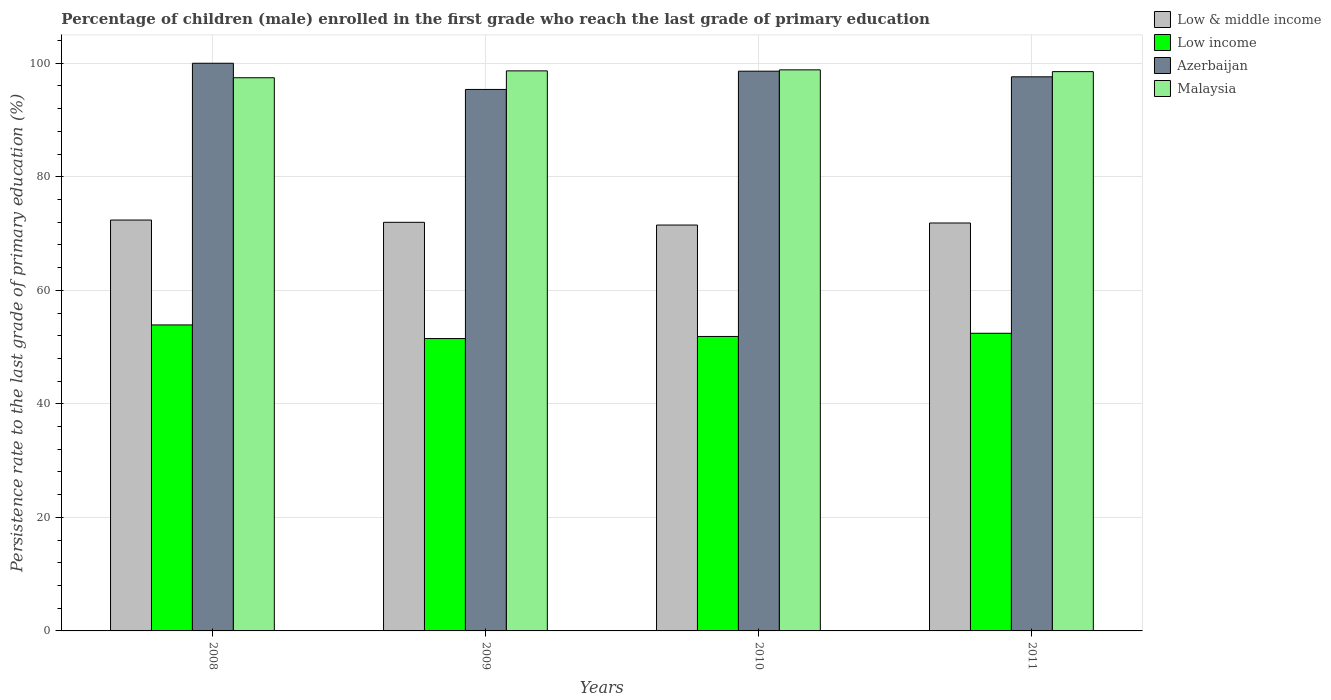How many different coloured bars are there?
Ensure brevity in your answer.  4. How many groups of bars are there?
Make the answer very short. 4. Are the number of bars on each tick of the X-axis equal?
Offer a very short reply. Yes. How many bars are there on the 2nd tick from the left?
Ensure brevity in your answer.  4. How many bars are there on the 4th tick from the right?
Make the answer very short. 4. What is the persistence rate of children in Low & middle income in 2010?
Ensure brevity in your answer.  71.49. Across all years, what is the maximum persistence rate of children in Azerbaijan?
Offer a very short reply. 99.99. Across all years, what is the minimum persistence rate of children in Low income?
Your response must be concise. 51.5. In which year was the persistence rate of children in Low & middle income maximum?
Ensure brevity in your answer.  2008. In which year was the persistence rate of children in Azerbaijan minimum?
Offer a terse response. 2009. What is the total persistence rate of children in Low & middle income in the graph?
Your answer should be compact. 287.7. What is the difference between the persistence rate of children in Malaysia in 2010 and that in 2011?
Your answer should be compact. 0.31. What is the difference between the persistence rate of children in Low income in 2008 and the persistence rate of children in Malaysia in 2009?
Provide a succinct answer. -44.75. What is the average persistence rate of children in Malaysia per year?
Keep it short and to the point. 98.36. In the year 2010, what is the difference between the persistence rate of children in Low income and persistence rate of children in Azerbaijan?
Your answer should be very brief. -46.73. What is the ratio of the persistence rate of children in Azerbaijan in 2009 to that in 2011?
Give a very brief answer. 0.98. Is the persistence rate of children in Azerbaijan in 2009 less than that in 2011?
Provide a succinct answer. Yes. Is the difference between the persistence rate of children in Low income in 2008 and 2011 greater than the difference between the persistence rate of children in Azerbaijan in 2008 and 2011?
Provide a succinct answer. No. What is the difference between the highest and the second highest persistence rate of children in Azerbaijan?
Your answer should be compact. 1.39. What is the difference between the highest and the lowest persistence rate of children in Malaysia?
Provide a short and direct response. 1.39. In how many years, is the persistence rate of children in Azerbaijan greater than the average persistence rate of children in Azerbaijan taken over all years?
Your answer should be compact. 2. Is the sum of the persistence rate of children in Low & middle income in 2010 and 2011 greater than the maximum persistence rate of children in Low income across all years?
Provide a succinct answer. Yes. Is it the case that in every year, the sum of the persistence rate of children in Low income and persistence rate of children in Malaysia is greater than the sum of persistence rate of children in Low & middle income and persistence rate of children in Azerbaijan?
Offer a very short reply. No. What does the 2nd bar from the left in 2009 represents?
Your answer should be very brief. Low income. What does the 1st bar from the right in 2010 represents?
Offer a terse response. Malaysia. How many bars are there?
Provide a succinct answer. 16. Are all the bars in the graph horizontal?
Offer a very short reply. No. What is the difference between two consecutive major ticks on the Y-axis?
Offer a very short reply. 20. Does the graph contain any zero values?
Provide a short and direct response. No. Does the graph contain grids?
Provide a succinct answer. Yes. Where does the legend appear in the graph?
Keep it short and to the point. Top right. How many legend labels are there?
Your answer should be compact. 4. What is the title of the graph?
Give a very brief answer. Percentage of children (male) enrolled in the first grade who reach the last grade of primary education. What is the label or title of the X-axis?
Offer a very short reply. Years. What is the label or title of the Y-axis?
Offer a terse response. Persistence rate to the last grade of primary education (%). What is the Persistence rate to the last grade of primary education (%) of Low & middle income in 2008?
Make the answer very short. 72.38. What is the Persistence rate to the last grade of primary education (%) in Low income in 2008?
Provide a short and direct response. 53.9. What is the Persistence rate to the last grade of primary education (%) of Azerbaijan in 2008?
Your response must be concise. 99.99. What is the Persistence rate to the last grade of primary education (%) in Malaysia in 2008?
Provide a succinct answer. 97.44. What is the Persistence rate to the last grade of primary education (%) of Low & middle income in 2009?
Give a very brief answer. 71.97. What is the Persistence rate to the last grade of primary education (%) in Low income in 2009?
Provide a succinct answer. 51.5. What is the Persistence rate to the last grade of primary education (%) in Azerbaijan in 2009?
Make the answer very short. 95.38. What is the Persistence rate to the last grade of primary education (%) of Malaysia in 2009?
Your answer should be very brief. 98.65. What is the Persistence rate to the last grade of primary education (%) in Low & middle income in 2010?
Offer a very short reply. 71.49. What is the Persistence rate to the last grade of primary education (%) in Low income in 2010?
Offer a very short reply. 51.87. What is the Persistence rate to the last grade of primary education (%) in Azerbaijan in 2010?
Give a very brief answer. 98.6. What is the Persistence rate to the last grade of primary education (%) of Malaysia in 2010?
Make the answer very short. 98.83. What is the Persistence rate to the last grade of primary education (%) of Low & middle income in 2011?
Your response must be concise. 71.86. What is the Persistence rate to the last grade of primary education (%) in Low income in 2011?
Make the answer very short. 52.43. What is the Persistence rate to the last grade of primary education (%) in Azerbaijan in 2011?
Ensure brevity in your answer.  97.6. What is the Persistence rate to the last grade of primary education (%) in Malaysia in 2011?
Provide a succinct answer. 98.52. Across all years, what is the maximum Persistence rate to the last grade of primary education (%) of Low & middle income?
Offer a very short reply. 72.38. Across all years, what is the maximum Persistence rate to the last grade of primary education (%) in Low income?
Your answer should be very brief. 53.9. Across all years, what is the maximum Persistence rate to the last grade of primary education (%) in Azerbaijan?
Make the answer very short. 99.99. Across all years, what is the maximum Persistence rate to the last grade of primary education (%) in Malaysia?
Keep it short and to the point. 98.83. Across all years, what is the minimum Persistence rate to the last grade of primary education (%) of Low & middle income?
Your response must be concise. 71.49. Across all years, what is the minimum Persistence rate to the last grade of primary education (%) in Low income?
Ensure brevity in your answer.  51.5. Across all years, what is the minimum Persistence rate to the last grade of primary education (%) in Azerbaijan?
Make the answer very short. 95.38. Across all years, what is the minimum Persistence rate to the last grade of primary education (%) in Malaysia?
Make the answer very short. 97.44. What is the total Persistence rate to the last grade of primary education (%) in Low & middle income in the graph?
Provide a succinct answer. 287.7. What is the total Persistence rate to the last grade of primary education (%) of Low income in the graph?
Offer a terse response. 209.7. What is the total Persistence rate to the last grade of primary education (%) of Azerbaijan in the graph?
Give a very brief answer. 391.58. What is the total Persistence rate to the last grade of primary education (%) of Malaysia in the graph?
Make the answer very short. 393.44. What is the difference between the Persistence rate to the last grade of primary education (%) of Low & middle income in 2008 and that in 2009?
Make the answer very short. 0.4. What is the difference between the Persistence rate to the last grade of primary education (%) of Low income in 2008 and that in 2009?
Ensure brevity in your answer.  2.4. What is the difference between the Persistence rate to the last grade of primary education (%) of Azerbaijan in 2008 and that in 2009?
Provide a succinct answer. 4.61. What is the difference between the Persistence rate to the last grade of primary education (%) in Malaysia in 2008 and that in 2009?
Make the answer very short. -1.21. What is the difference between the Persistence rate to the last grade of primary education (%) of Low & middle income in 2008 and that in 2010?
Your response must be concise. 0.88. What is the difference between the Persistence rate to the last grade of primary education (%) in Low income in 2008 and that in 2010?
Offer a very short reply. 2.03. What is the difference between the Persistence rate to the last grade of primary education (%) in Azerbaijan in 2008 and that in 2010?
Your answer should be compact. 1.39. What is the difference between the Persistence rate to the last grade of primary education (%) of Malaysia in 2008 and that in 2010?
Your answer should be compact. -1.39. What is the difference between the Persistence rate to the last grade of primary education (%) of Low & middle income in 2008 and that in 2011?
Ensure brevity in your answer.  0.52. What is the difference between the Persistence rate to the last grade of primary education (%) of Low income in 2008 and that in 2011?
Provide a short and direct response. 1.47. What is the difference between the Persistence rate to the last grade of primary education (%) in Azerbaijan in 2008 and that in 2011?
Keep it short and to the point. 2.39. What is the difference between the Persistence rate to the last grade of primary education (%) of Malaysia in 2008 and that in 2011?
Make the answer very short. -1.08. What is the difference between the Persistence rate to the last grade of primary education (%) in Low & middle income in 2009 and that in 2010?
Your answer should be compact. 0.48. What is the difference between the Persistence rate to the last grade of primary education (%) of Low income in 2009 and that in 2010?
Provide a short and direct response. -0.37. What is the difference between the Persistence rate to the last grade of primary education (%) in Azerbaijan in 2009 and that in 2010?
Keep it short and to the point. -3.22. What is the difference between the Persistence rate to the last grade of primary education (%) in Malaysia in 2009 and that in 2010?
Offer a terse response. -0.18. What is the difference between the Persistence rate to the last grade of primary education (%) in Low & middle income in 2009 and that in 2011?
Keep it short and to the point. 0.12. What is the difference between the Persistence rate to the last grade of primary education (%) of Low income in 2009 and that in 2011?
Your response must be concise. -0.93. What is the difference between the Persistence rate to the last grade of primary education (%) of Azerbaijan in 2009 and that in 2011?
Give a very brief answer. -2.22. What is the difference between the Persistence rate to the last grade of primary education (%) in Malaysia in 2009 and that in 2011?
Your response must be concise. 0.13. What is the difference between the Persistence rate to the last grade of primary education (%) in Low & middle income in 2010 and that in 2011?
Provide a short and direct response. -0.36. What is the difference between the Persistence rate to the last grade of primary education (%) in Low income in 2010 and that in 2011?
Provide a succinct answer. -0.56. What is the difference between the Persistence rate to the last grade of primary education (%) of Azerbaijan in 2010 and that in 2011?
Provide a short and direct response. 0.99. What is the difference between the Persistence rate to the last grade of primary education (%) of Malaysia in 2010 and that in 2011?
Provide a succinct answer. 0.31. What is the difference between the Persistence rate to the last grade of primary education (%) in Low & middle income in 2008 and the Persistence rate to the last grade of primary education (%) in Low income in 2009?
Your answer should be compact. 20.87. What is the difference between the Persistence rate to the last grade of primary education (%) of Low & middle income in 2008 and the Persistence rate to the last grade of primary education (%) of Azerbaijan in 2009?
Provide a succinct answer. -23. What is the difference between the Persistence rate to the last grade of primary education (%) in Low & middle income in 2008 and the Persistence rate to the last grade of primary education (%) in Malaysia in 2009?
Provide a short and direct response. -26.28. What is the difference between the Persistence rate to the last grade of primary education (%) in Low income in 2008 and the Persistence rate to the last grade of primary education (%) in Azerbaijan in 2009?
Offer a terse response. -41.48. What is the difference between the Persistence rate to the last grade of primary education (%) of Low income in 2008 and the Persistence rate to the last grade of primary education (%) of Malaysia in 2009?
Give a very brief answer. -44.75. What is the difference between the Persistence rate to the last grade of primary education (%) in Azerbaijan in 2008 and the Persistence rate to the last grade of primary education (%) in Malaysia in 2009?
Offer a terse response. 1.34. What is the difference between the Persistence rate to the last grade of primary education (%) in Low & middle income in 2008 and the Persistence rate to the last grade of primary education (%) in Low income in 2010?
Your answer should be very brief. 20.51. What is the difference between the Persistence rate to the last grade of primary education (%) in Low & middle income in 2008 and the Persistence rate to the last grade of primary education (%) in Azerbaijan in 2010?
Offer a very short reply. -26.22. What is the difference between the Persistence rate to the last grade of primary education (%) of Low & middle income in 2008 and the Persistence rate to the last grade of primary education (%) of Malaysia in 2010?
Your answer should be compact. -26.46. What is the difference between the Persistence rate to the last grade of primary education (%) of Low income in 2008 and the Persistence rate to the last grade of primary education (%) of Azerbaijan in 2010?
Your response must be concise. -44.7. What is the difference between the Persistence rate to the last grade of primary education (%) in Low income in 2008 and the Persistence rate to the last grade of primary education (%) in Malaysia in 2010?
Offer a terse response. -44.93. What is the difference between the Persistence rate to the last grade of primary education (%) in Azerbaijan in 2008 and the Persistence rate to the last grade of primary education (%) in Malaysia in 2010?
Your answer should be compact. 1.16. What is the difference between the Persistence rate to the last grade of primary education (%) of Low & middle income in 2008 and the Persistence rate to the last grade of primary education (%) of Low income in 2011?
Your response must be concise. 19.95. What is the difference between the Persistence rate to the last grade of primary education (%) of Low & middle income in 2008 and the Persistence rate to the last grade of primary education (%) of Azerbaijan in 2011?
Offer a terse response. -25.23. What is the difference between the Persistence rate to the last grade of primary education (%) in Low & middle income in 2008 and the Persistence rate to the last grade of primary education (%) in Malaysia in 2011?
Offer a terse response. -26.14. What is the difference between the Persistence rate to the last grade of primary education (%) in Low income in 2008 and the Persistence rate to the last grade of primary education (%) in Azerbaijan in 2011?
Your response must be concise. -43.7. What is the difference between the Persistence rate to the last grade of primary education (%) of Low income in 2008 and the Persistence rate to the last grade of primary education (%) of Malaysia in 2011?
Offer a terse response. -44.62. What is the difference between the Persistence rate to the last grade of primary education (%) in Azerbaijan in 2008 and the Persistence rate to the last grade of primary education (%) in Malaysia in 2011?
Make the answer very short. 1.48. What is the difference between the Persistence rate to the last grade of primary education (%) of Low & middle income in 2009 and the Persistence rate to the last grade of primary education (%) of Low income in 2010?
Keep it short and to the point. 20.11. What is the difference between the Persistence rate to the last grade of primary education (%) in Low & middle income in 2009 and the Persistence rate to the last grade of primary education (%) in Azerbaijan in 2010?
Provide a succinct answer. -26.62. What is the difference between the Persistence rate to the last grade of primary education (%) in Low & middle income in 2009 and the Persistence rate to the last grade of primary education (%) in Malaysia in 2010?
Keep it short and to the point. -26.86. What is the difference between the Persistence rate to the last grade of primary education (%) in Low income in 2009 and the Persistence rate to the last grade of primary education (%) in Azerbaijan in 2010?
Offer a very short reply. -47.1. What is the difference between the Persistence rate to the last grade of primary education (%) in Low income in 2009 and the Persistence rate to the last grade of primary education (%) in Malaysia in 2010?
Your answer should be very brief. -47.33. What is the difference between the Persistence rate to the last grade of primary education (%) in Azerbaijan in 2009 and the Persistence rate to the last grade of primary education (%) in Malaysia in 2010?
Make the answer very short. -3.45. What is the difference between the Persistence rate to the last grade of primary education (%) of Low & middle income in 2009 and the Persistence rate to the last grade of primary education (%) of Low income in 2011?
Make the answer very short. 19.54. What is the difference between the Persistence rate to the last grade of primary education (%) of Low & middle income in 2009 and the Persistence rate to the last grade of primary education (%) of Azerbaijan in 2011?
Your answer should be compact. -25.63. What is the difference between the Persistence rate to the last grade of primary education (%) in Low & middle income in 2009 and the Persistence rate to the last grade of primary education (%) in Malaysia in 2011?
Provide a short and direct response. -26.54. What is the difference between the Persistence rate to the last grade of primary education (%) of Low income in 2009 and the Persistence rate to the last grade of primary education (%) of Azerbaijan in 2011?
Offer a very short reply. -46.1. What is the difference between the Persistence rate to the last grade of primary education (%) in Low income in 2009 and the Persistence rate to the last grade of primary education (%) in Malaysia in 2011?
Your response must be concise. -47.02. What is the difference between the Persistence rate to the last grade of primary education (%) in Azerbaijan in 2009 and the Persistence rate to the last grade of primary education (%) in Malaysia in 2011?
Provide a succinct answer. -3.14. What is the difference between the Persistence rate to the last grade of primary education (%) in Low & middle income in 2010 and the Persistence rate to the last grade of primary education (%) in Low income in 2011?
Give a very brief answer. 19.06. What is the difference between the Persistence rate to the last grade of primary education (%) in Low & middle income in 2010 and the Persistence rate to the last grade of primary education (%) in Azerbaijan in 2011?
Offer a terse response. -26.11. What is the difference between the Persistence rate to the last grade of primary education (%) in Low & middle income in 2010 and the Persistence rate to the last grade of primary education (%) in Malaysia in 2011?
Offer a very short reply. -27.02. What is the difference between the Persistence rate to the last grade of primary education (%) of Low income in 2010 and the Persistence rate to the last grade of primary education (%) of Azerbaijan in 2011?
Offer a very short reply. -45.73. What is the difference between the Persistence rate to the last grade of primary education (%) of Low income in 2010 and the Persistence rate to the last grade of primary education (%) of Malaysia in 2011?
Give a very brief answer. -46.65. What is the difference between the Persistence rate to the last grade of primary education (%) in Azerbaijan in 2010 and the Persistence rate to the last grade of primary education (%) in Malaysia in 2011?
Provide a succinct answer. 0.08. What is the average Persistence rate to the last grade of primary education (%) of Low & middle income per year?
Offer a very short reply. 71.93. What is the average Persistence rate to the last grade of primary education (%) in Low income per year?
Ensure brevity in your answer.  52.43. What is the average Persistence rate to the last grade of primary education (%) in Azerbaijan per year?
Give a very brief answer. 97.89. What is the average Persistence rate to the last grade of primary education (%) of Malaysia per year?
Your response must be concise. 98.36. In the year 2008, what is the difference between the Persistence rate to the last grade of primary education (%) of Low & middle income and Persistence rate to the last grade of primary education (%) of Low income?
Your response must be concise. 18.47. In the year 2008, what is the difference between the Persistence rate to the last grade of primary education (%) of Low & middle income and Persistence rate to the last grade of primary education (%) of Azerbaijan?
Make the answer very short. -27.62. In the year 2008, what is the difference between the Persistence rate to the last grade of primary education (%) of Low & middle income and Persistence rate to the last grade of primary education (%) of Malaysia?
Provide a short and direct response. -25.07. In the year 2008, what is the difference between the Persistence rate to the last grade of primary education (%) in Low income and Persistence rate to the last grade of primary education (%) in Azerbaijan?
Your answer should be very brief. -46.09. In the year 2008, what is the difference between the Persistence rate to the last grade of primary education (%) of Low income and Persistence rate to the last grade of primary education (%) of Malaysia?
Your response must be concise. -43.54. In the year 2008, what is the difference between the Persistence rate to the last grade of primary education (%) of Azerbaijan and Persistence rate to the last grade of primary education (%) of Malaysia?
Your response must be concise. 2.55. In the year 2009, what is the difference between the Persistence rate to the last grade of primary education (%) in Low & middle income and Persistence rate to the last grade of primary education (%) in Low income?
Keep it short and to the point. 20.47. In the year 2009, what is the difference between the Persistence rate to the last grade of primary education (%) in Low & middle income and Persistence rate to the last grade of primary education (%) in Azerbaijan?
Keep it short and to the point. -23.4. In the year 2009, what is the difference between the Persistence rate to the last grade of primary education (%) in Low & middle income and Persistence rate to the last grade of primary education (%) in Malaysia?
Your answer should be compact. -26.68. In the year 2009, what is the difference between the Persistence rate to the last grade of primary education (%) of Low income and Persistence rate to the last grade of primary education (%) of Azerbaijan?
Make the answer very short. -43.88. In the year 2009, what is the difference between the Persistence rate to the last grade of primary education (%) in Low income and Persistence rate to the last grade of primary education (%) in Malaysia?
Make the answer very short. -47.15. In the year 2009, what is the difference between the Persistence rate to the last grade of primary education (%) of Azerbaijan and Persistence rate to the last grade of primary education (%) of Malaysia?
Keep it short and to the point. -3.27. In the year 2010, what is the difference between the Persistence rate to the last grade of primary education (%) in Low & middle income and Persistence rate to the last grade of primary education (%) in Low income?
Your answer should be compact. 19.63. In the year 2010, what is the difference between the Persistence rate to the last grade of primary education (%) in Low & middle income and Persistence rate to the last grade of primary education (%) in Azerbaijan?
Offer a terse response. -27.1. In the year 2010, what is the difference between the Persistence rate to the last grade of primary education (%) in Low & middle income and Persistence rate to the last grade of primary education (%) in Malaysia?
Offer a terse response. -27.34. In the year 2010, what is the difference between the Persistence rate to the last grade of primary education (%) of Low income and Persistence rate to the last grade of primary education (%) of Azerbaijan?
Provide a short and direct response. -46.73. In the year 2010, what is the difference between the Persistence rate to the last grade of primary education (%) of Low income and Persistence rate to the last grade of primary education (%) of Malaysia?
Ensure brevity in your answer.  -46.96. In the year 2010, what is the difference between the Persistence rate to the last grade of primary education (%) of Azerbaijan and Persistence rate to the last grade of primary education (%) of Malaysia?
Offer a very short reply. -0.23. In the year 2011, what is the difference between the Persistence rate to the last grade of primary education (%) in Low & middle income and Persistence rate to the last grade of primary education (%) in Low income?
Offer a very short reply. 19.43. In the year 2011, what is the difference between the Persistence rate to the last grade of primary education (%) in Low & middle income and Persistence rate to the last grade of primary education (%) in Azerbaijan?
Offer a terse response. -25.75. In the year 2011, what is the difference between the Persistence rate to the last grade of primary education (%) of Low & middle income and Persistence rate to the last grade of primary education (%) of Malaysia?
Your response must be concise. -26.66. In the year 2011, what is the difference between the Persistence rate to the last grade of primary education (%) of Low income and Persistence rate to the last grade of primary education (%) of Azerbaijan?
Offer a terse response. -45.17. In the year 2011, what is the difference between the Persistence rate to the last grade of primary education (%) of Low income and Persistence rate to the last grade of primary education (%) of Malaysia?
Provide a short and direct response. -46.09. In the year 2011, what is the difference between the Persistence rate to the last grade of primary education (%) of Azerbaijan and Persistence rate to the last grade of primary education (%) of Malaysia?
Offer a very short reply. -0.91. What is the ratio of the Persistence rate to the last grade of primary education (%) in Low & middle income in 2008 to that in 2009?
Offer a very short reply. 1.01. What is the ratio of the Persistence rate to the last grade of primary education (%) in Low income in 2008 to that in 2009?
Provide a short and direct response. 1.05. What is the ratio of the Persistence rate to the last grade of primary education (%) in Azerbaijan in 2008 to that in 2009?
Your answer should be very brief. 1.05. What is the ratio of the Persistence rate to the last grade of primary education (%) in Malaysia in 2008 to that in 2009?
Provide a succinct answer. 0.99. What is the ratio of the Persistence rate to the last grade of primary education (%) of Low & middle income in 2008 to that in 2010?
Keep it short and to the point. 1.01. What is the ratio of the Persistence rate to the last grade of primary education (%) in Low income in 2008 to that in 2010?
Your answer should be very brief. 1.04. What is the ratio of the Persistence rate to the last grade of primary education (%) in Azerbaijan in 2008 to that in 2010?
Make the answer very short. 1.01. What is the ratio of the Persistence rate to the last grade of primary education (%) in Malaysia in 2008 to that in 2010?
Give a very brief answer. 0.99. What is the ratio of the Persistence rate to the last grade of primary education (%) in Low income in 2008 to that in 2011?
Give a very brief answer. 1.03. What is the ratio of the Persistence rate to the last grade of primary education (%) of Azerbaijan in 2008 to that in 2011?
Make the answer very short. 1.02. What is the ratio of the Persistence rate to the last grade of primary education (%) in Low income in 2009 to that in 2010?
Offer a terse response. 0.99. What is the ratio of the Persistence rate to the last grade of primary education (%) in Azerbaijan in 2009 to that in 2010?
Keep it short and to the point. 0.97. What is the ratio of the Persistence rate to the last grade of primary education (%) of Low income in 2009 to that in 2011?
Make the answer very short. 0.98. What is the ratio of the Persistence rate to the last grade of primary education (%) of Azerbaijan in 2009 to that in 2011?
Provide a short and direct response. 0.98. What is the ratio of the Persistence rate to the last grade of primary education (%) of Low income in 2010 to that in 2011?
Give a very brief answer. 0.99. What is the ratio of the Persistence rate to the last grade of primary education (%) of Azerbaijan in 2010 to that in 2011?
Your answer should be compact. 1.01. What is the ratio of the Persistence rate to the last grade of primary education (%) in Malaysia in 2010 to that in 2011?
Provide a succinct answer. 1. What is the difference between the highest and the second highest Persistence rate to the last grade of primary education (%) in Low & middle income?
Your answer should be compact. 0.4. What is the difference between the highest and the second highest Persistence rate to the last grade of primary education (%) of Low income?
Ensure brevity in your answer.  1.47. What is the difference between the highest and the second highest Persistence rate to the last grade of primary education (%) in Azerbaijan?
Keep it short and to the point. 1.39. What is the difference between the highest and the second highest Persistence rate to the last grade of primary education (%) of Malaysia?
Your answer should be compact. 0.18. What is the difference between the highest and the lowest Persistence rate to the last grade of primary education (%) of Low & middle income?
Ensure brevity in your answer.  0.88. What is the difference between the highest and the lowest Persistence rate to the last grade of primary education (%) of Azerbaijan?
Ensure brevity in your answer.  4.61. What is the difference between the highest and the lowest Persistence rate to the last grade of primary education (%) of Malaysia?
Offer a very short reply. 1.39. 